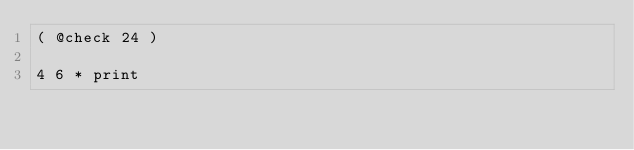Convert code to text. <code><loc_0><loc_0><loc_500><loc_500><_Forth_>( @check 24 )

4 6 * print
</code> 